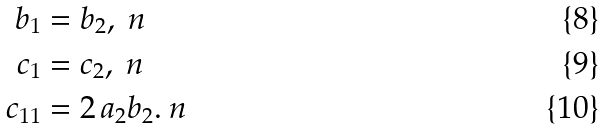<formula> <loc_0><loc_0><loc_500><loc_500>b _ { 1 } & = b _ { 2 } , \ n \\ c _ { 1 } & = c _ { 2 } , \ n \\ c _ { 1 1 } & = 2 \, a _ { 2 } b _ { 2 } . \ n</formula> 